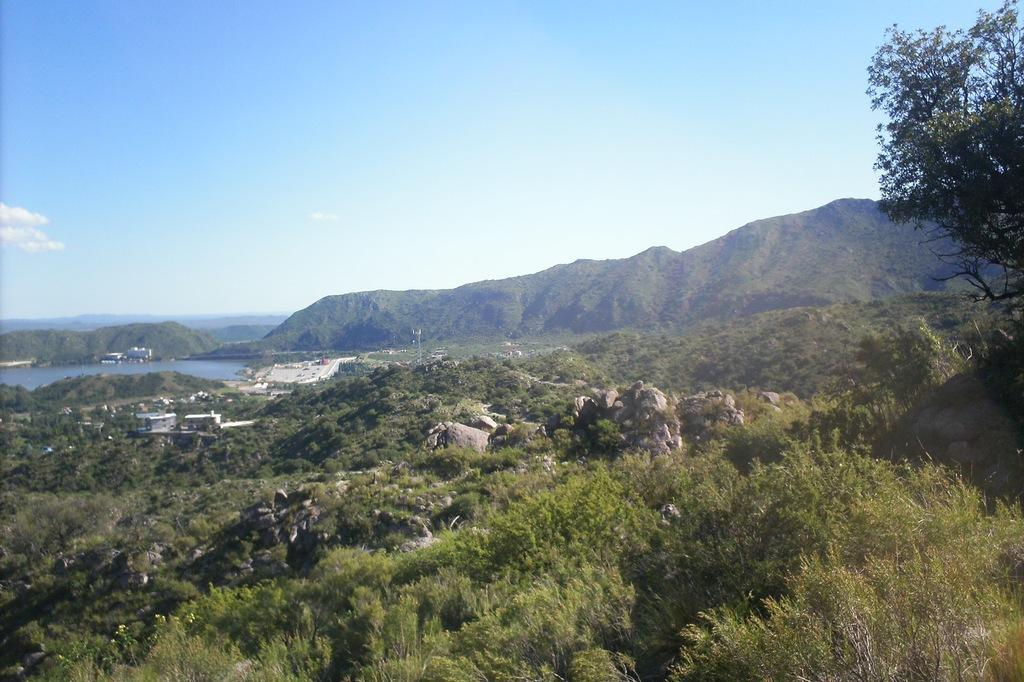What type of natural elements can be seen in the image? There are trees and stones visible in the image. What type of man-made structures are present in the image? There are houses in the image. What is the water feature in the image? There is water visible in the image. What type of landscape can be seen in the background of the image? There are mountains in the background of the image. What is the condition of the sky in the image? The sky is cloudy in the image. What type of art can be seen hanging on the trees in the image? There is no art hanging on the trees in the image; only trees, stones, houses, water, mountains, and a cloudy sky are present. 